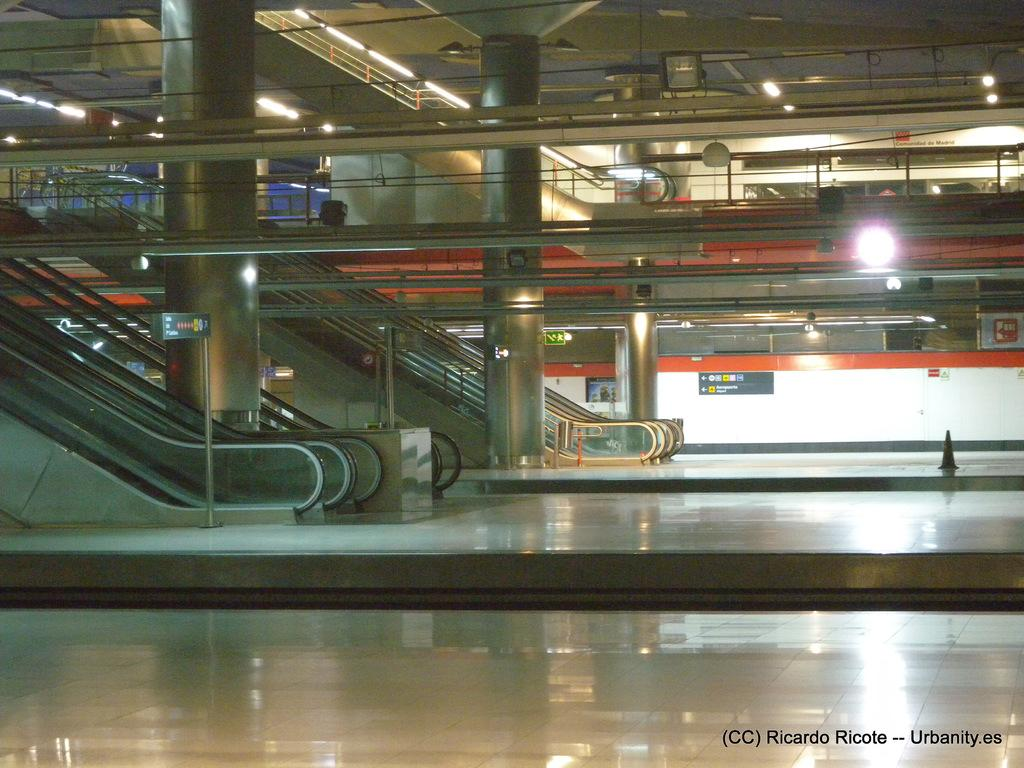What type of transportation equipment is present in the image? There are escalators in the image. What architectural elements can be seen in the image? There are pillars and rods in the image. What type of illumination is present in the image? There are lights in the image. What type of decorations are on the walls in the image? There are posters on the wall in the image. Is there any additional information about the image itself? There is a watermark in the right bottom corner of the image. How many eggs are being rubbed on the posters in the image? There are no eggs or rubbing actions present in the image. What is the interest rate for the escalators in the image? The image does not contain any information about interest rates, as it features escalators, pillars, rods, lights, posters, and a watermark. 